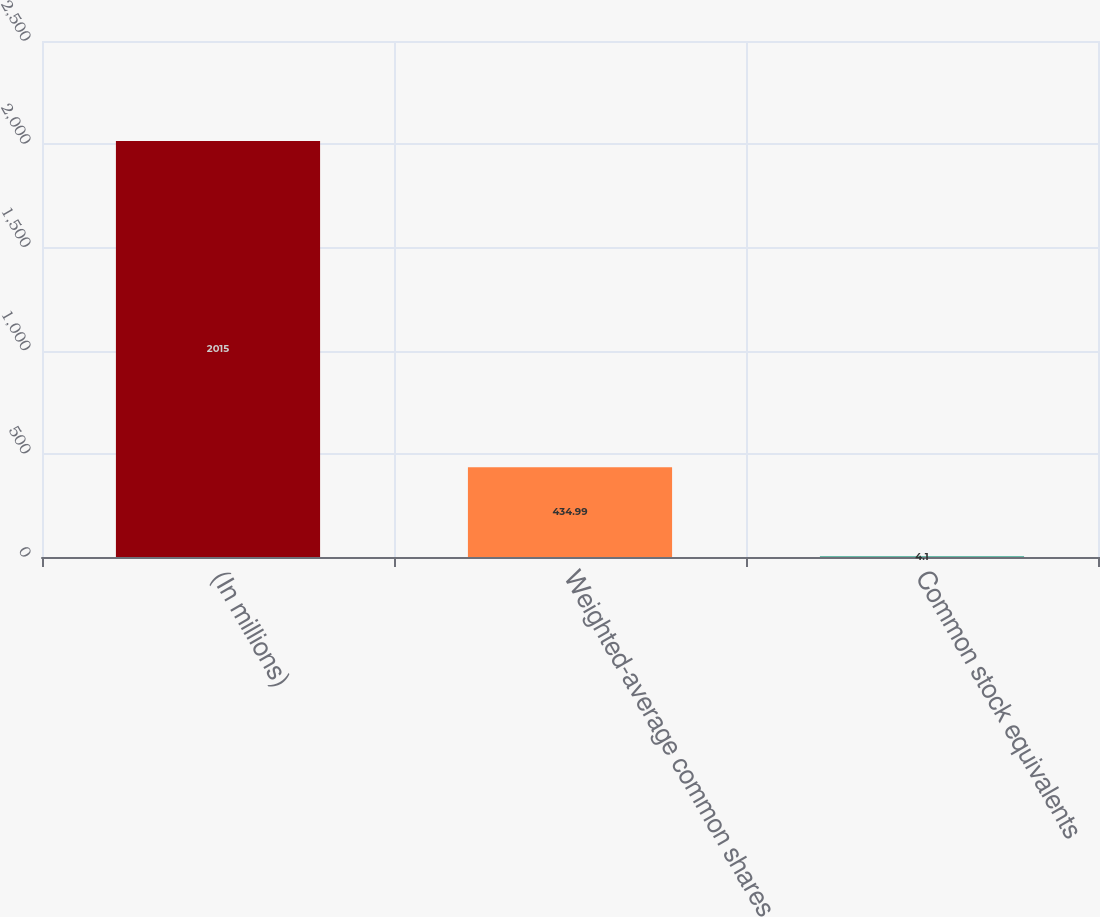Convert chart to OTSL. <chart><loc_0><loc_0><loc_500><loc_500><bar_chart><fcel>(In millions)<fcel>Weighted-average common shares<fcel>Common stock equivalents<nl><fcel>2015<fcel>434.99<fcel>4.1<nl></chart> 